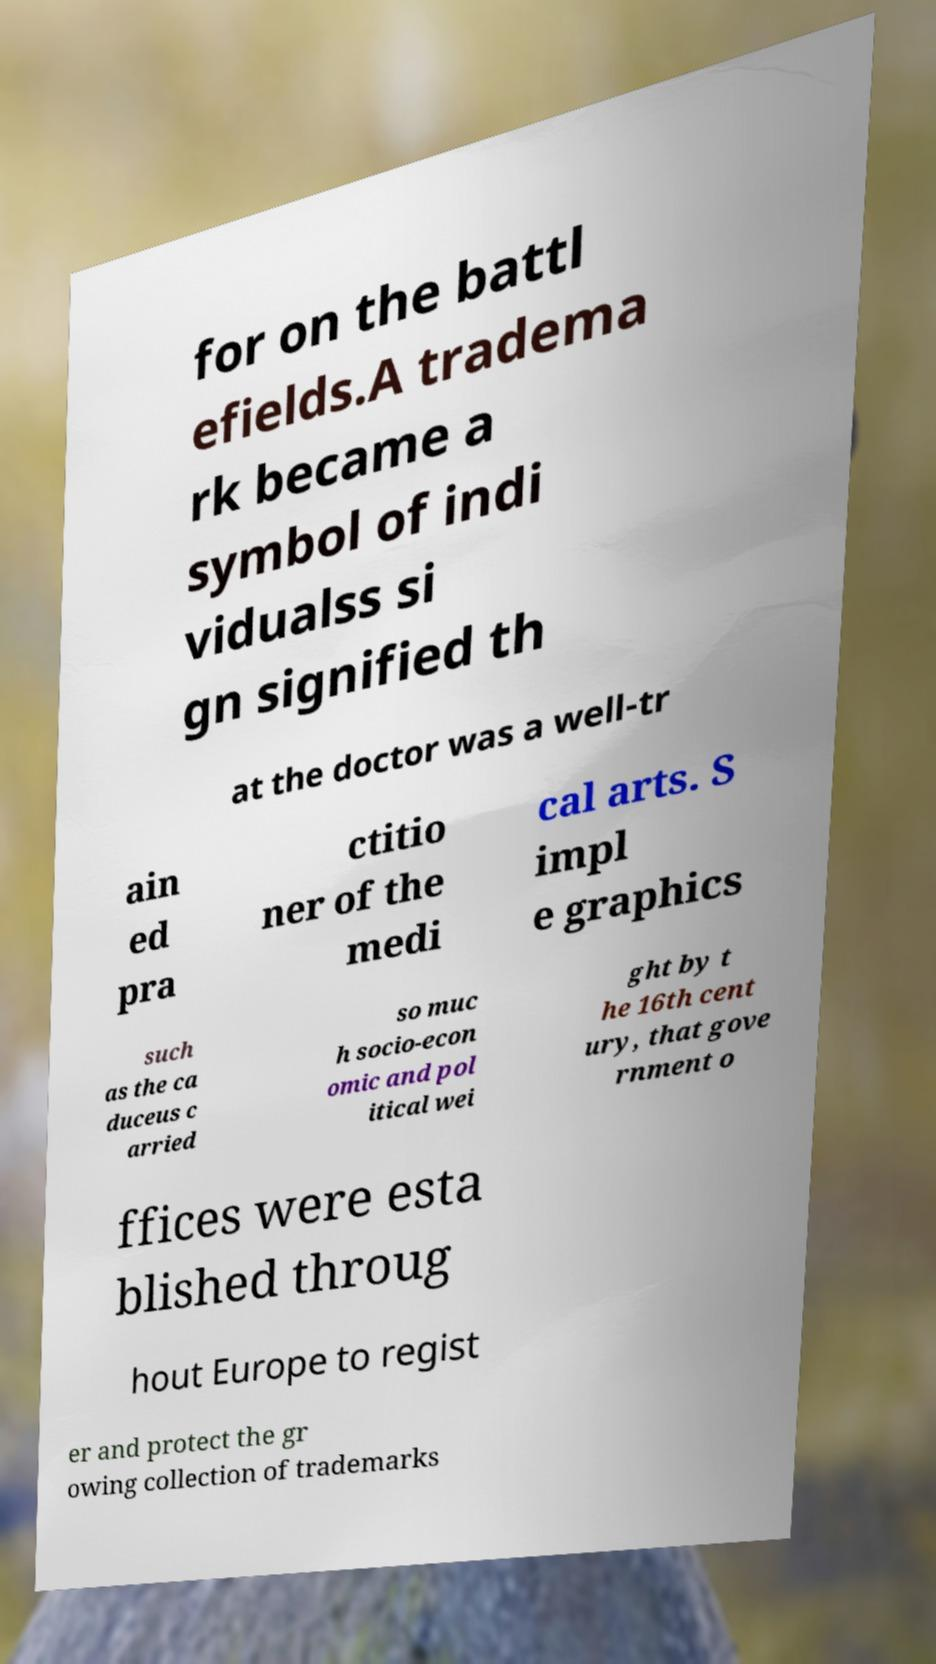Can you read and provide the text displayed in the image?This photo seems to have some interesting text. Can you extract and type it out for me? for on the battl efields.A tradema rk became a symbol of indi vidualss si gn signified th at the doctor was a well-tr ain ed pra ctitio ner of the medi cal arts. S impl e graphics such as the ca duceus c arried so muc h socio-econ omic and pol itical wei ght by t he 16th cent ury, that gove rnment o ffices were esta blished throug hout Europe to regist er and protect the gr owing collection of trademarks 